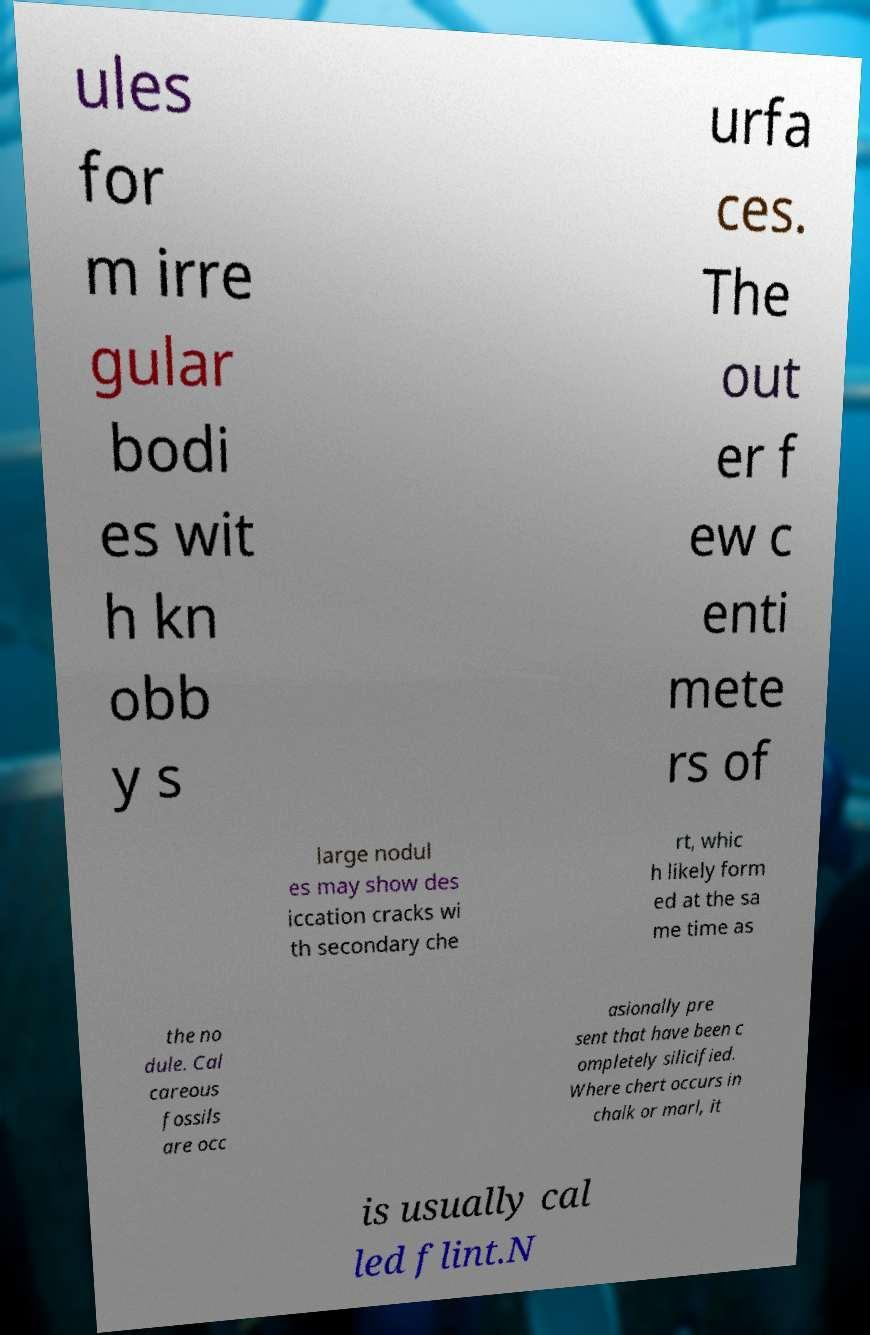Please read and relay the text visible in this image. What does it say? ules for m irre gular bodi es wit h kn obb y s urfa ces. The out er f ew c enti mete rs of large nodul es may show des iccation cracks wi th secondary che rt, whic h likely form ed at the sa me time as the no dule. Cal careous fossils are occ asionally pre sent that have been c ompletely silicified. Where chert occurs in chalk or marl, it is usually cal led flint.N 